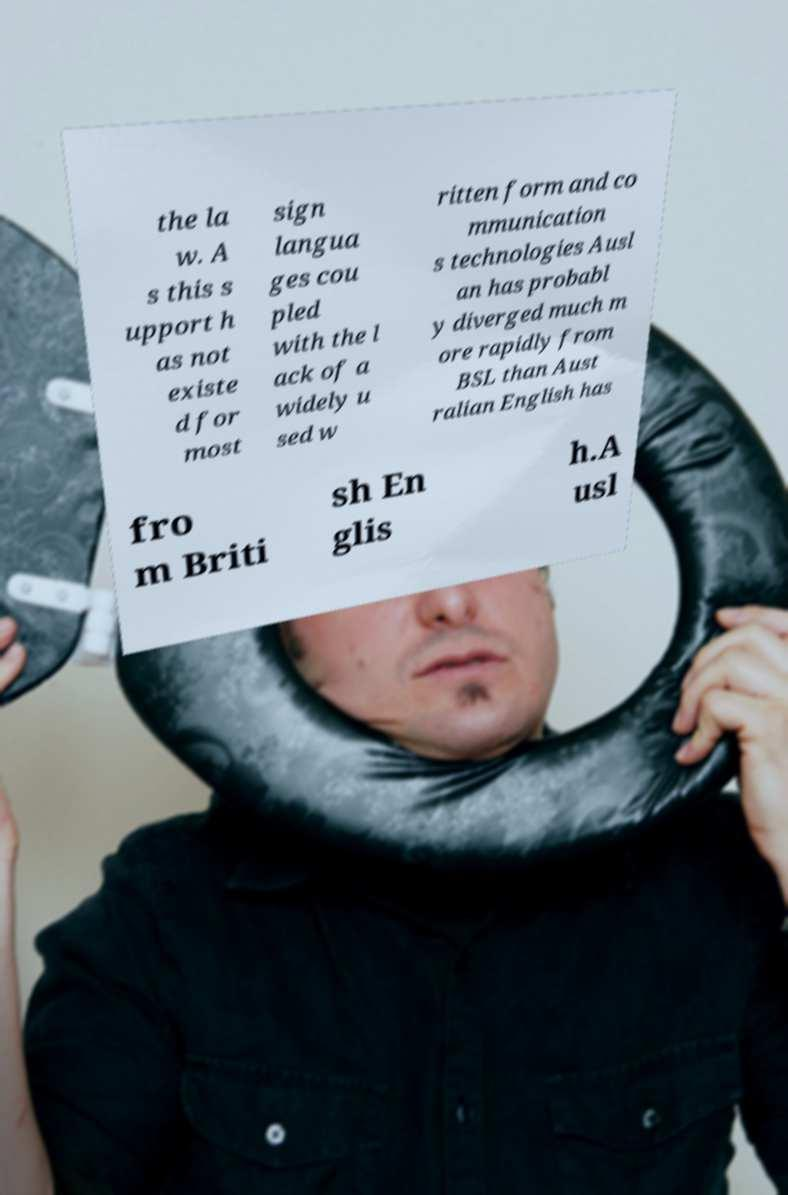Can you accurately transcribe the text from the provided image for me? the la w. A s this s upport h as not existe d for most sign langua ges cou pled with the l ack of a widely u sed w ritten form and co mmunication s technologies Ausl an has probabl y diverged much m ore rapidly from BSL than Aust ralian English has fro m Briti sh En glis h.A usl 